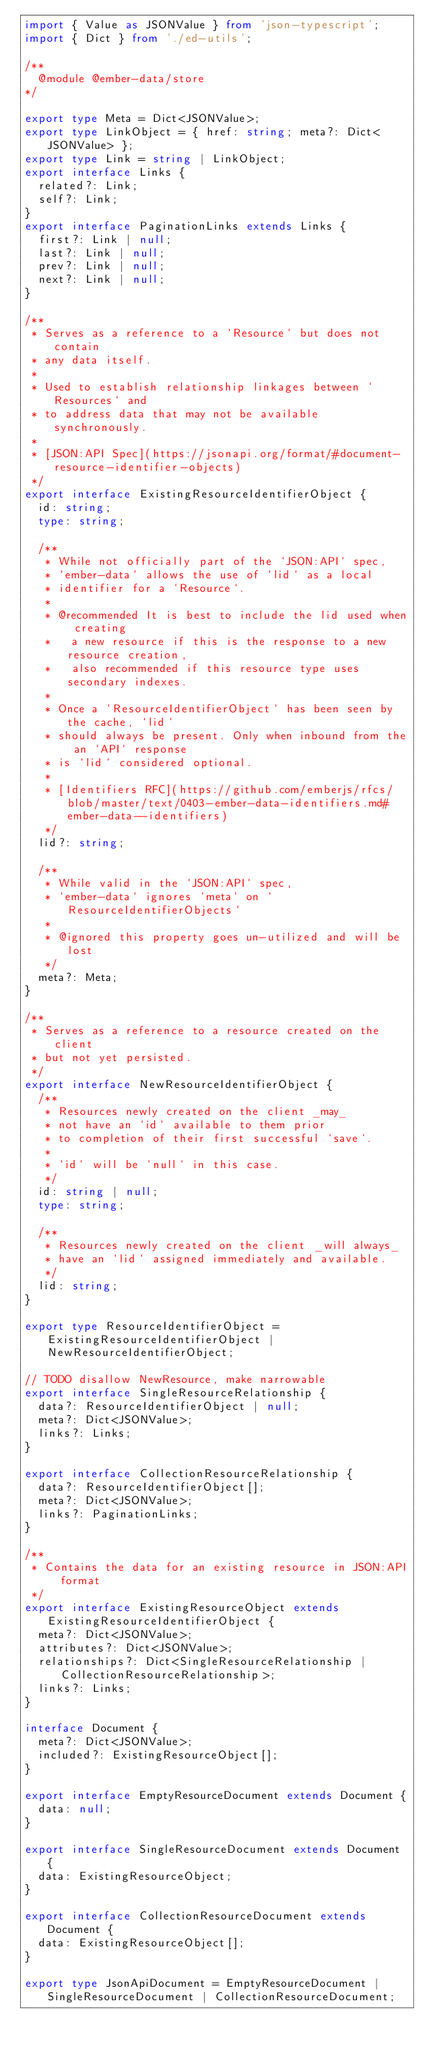Convert code to text. <code><loc_0><loc_0><loc_500><loc_500><_TypeScript_>import { Value as JSONValue } from 'json-typescript';
import { Dict } from './ed-utils';

/**
  @module @ember-data/store
*/

export type Meta = Dict<JSONValue>;
export type LinkObject = { href: string; meta?: Dict<JSONValue> };
export type Link = string | LinkObject;
export interface Links {
  related?: Link;
  self?: Link;
}
export interface PaginationLinks extends Links {
  first?: Link | null;
  last?: Link | null;
  prev?: Link | null;
  next?: Link | null;
}

/**
 * Serves as a reference to a `Resource` but does not contain
 * any data itself.
 *
 * Used to establish relationship linkages between `Resources` and
 * to address data that may not be available synchronously.
 *
 * [JSON:API Spec](https://jsonapi.org/format/#document-resource-identifier-objects)
 */
export interface ExistingResourceIdentifierObject {
  id: string;
  type: string;

  /**
   * While not officially part of the `JSON:API` spec,
   * `ember-data` allows the use of `lid` as a local
   * identifier for a `Resource`.
   *
   * @recommended It is best to include the lid used when creating
   *   a new resource if this is the response to a new resource creation,
   *   also recommended if this resource type uses secondary indexes.
   *
   * Once a `ResourceIdentifierObject` has been seen by the cache, `lid`
   * should always be present. Only when inbound from the an `API` response
   * is `lid` considered optional.
   *
   * [Identifiers RFC](https://github.com/emberjs/rfcs/blob/master/text/0403-ember-data-identifiers.md#ember-data--identifiers)
   */
  lid?: string;

  /**
   * While valid in the `JSON:API` spec,
   * `ember-data` ignores `meta` on `ResourceIdentifierObjects`
   *
   * @ignored this property goes un-utilized and will be lost
   */
  meta?: Meta;
}

/**
 * Serves as a reference to a resource created on the client
 * but not yet persisted.
 */
export interface NewResourceIdentifierObject {
  /**
   * Resources newly created on the client _may_
   * not have an `id` available to them prior
   * to completion of their first successful `save`.
   *
   * `id` will be `null` in this case.
   */
  id: string | null;
  type: string;

  /**
   * Resources newly created on the client _will always_
   * have an `lid` assigned immediately and available.
   */
  lid: string;
}

export type ResourceIdentifierObject = ExistingResourceIdentifierObject | NewResourceIdentifierObject;

// TODO disallow NewResource, make narrowable
export interface SingleResourceRelationship {
  data?: ResourceIdentifierObject | null;
  meta?: Dict<JSONValue>;
  links?: Links;
}

export interface CollectionResourceRelationship {
  data?: ResourceIdentifierObject[];
  meta?: Dict<JSONValue>;
  links?: PaginationLinks;
}

/**
 * Contains the data for an existing resource in JSON:API format
 */
export interface ExistingResourceObject extends ExistingResourceIdentifierObject {
  meta?: Dict<JSONValue>;
  attributes?: Dict<JSONValue>;
  relationships?: Dict<SingleResourceRelationship | CollectionResourceRelationship>;
  links?: Links;
}

interface Document {
  meta?: Dict<JSONValue>;
  included?: ExistingResourceObject[];
}

export interface EmptyResourceDocument extends Document {
  data: null;
}

export interface SingleResourceDocument extends Document {
  data: ExistingResourceObject;
}

export interface CollectionResourceDocument extends Document {
  data: ExistingResourceObject[];
}

export type JsonApiDocument = EmptyResourceDocument | SingleResourceDocument | CollectionResourceDocument;</code> 